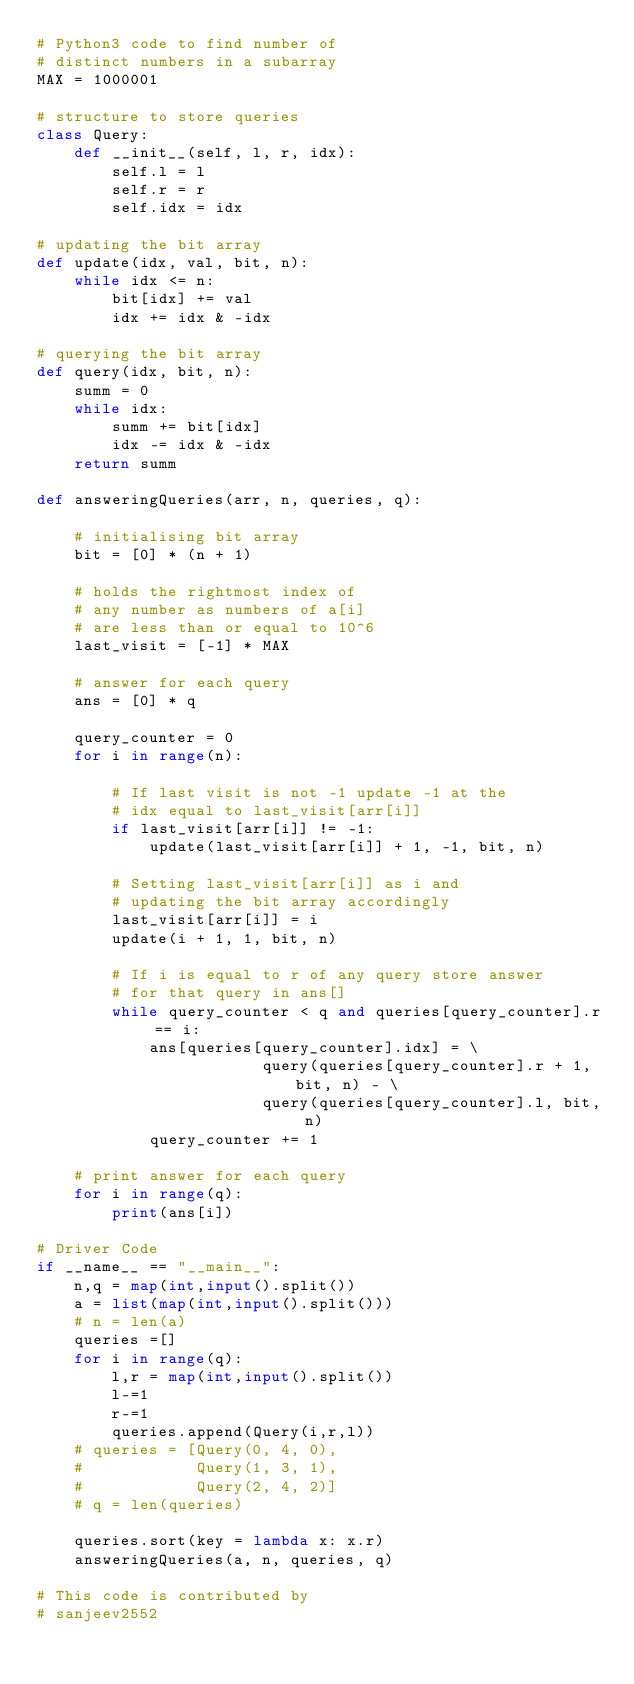<code> <loc_0><loc_0><loc_500><loc_500><_Python_># Python3 code to find number of  
# distinct numbers in a subarray 
MAX = 1000001
  
# structure to store queries 
class Query: 
    def __init__(self, l, r, idx): 
        self.l = l 
        self.r = r 
        self.idx = idx 
  
# updating the bit array 
def update(idx, val, bit, n): 
    while idx <= n: 
        bit[idx] += val 
        idx += idx & -idx 
  
# querying the bit array 
def query(idx, bit, n): 
    summ = 0
    while idx: 
        summ += bit[idx] 
        idx -= idx & -idx 
    return summ 
  
def answeringQueries(arr, n, queries, q): 
  
    # initialising bit array 
    bit = [0] * (n + 1) 
  
    # holds the rightmost index of  
    # any number as numbers of a[i] 
    # are less than or equal to 10^6 
    last_visit = [-1] * MAX
  
    # answer for each query 
    ans = [0] * q 
  
    query_counter = 0
    for i in range(n): 
  
        # If last visit is not -1 update -1 at the 
        # idx equal to last_visit[arr[i]] 
        if last_visit[arr[i]] != -1: 
            update(last_visit[arr[i]] + 1, -1, bit, n) 
  
        # Setting last_visit[arr[i]] as i and  
        # updating the bit array accordingly 
        last_visit[arr[i]] = i 
        update(i + 1, 1, bit, n) 
  
        # If i is equal to r of any query store answer 
        # for that query in ans[] 
        while query_counter < q and queries[query_counter].r == i: 
            ans[queries[query_counter].idx] = \ 
                        query(queries[query_counter].r + 1, bit, n) - \ 
                        query(queries[query_counter].l, bit, n) 
            query_counter += 1
  
    # print answer for each query 
    for i in range(q): 
        print(ans[i]) 
  
# Driver Code 
if __name__ == "__main__":
    n,q = map(int,input().split())
    a = list(map(int,input().split()))
    # n = len(a)
    queries =[]
    for i in range(q):
        l,r = map(int,input().split())
        l-=1
        r-=1
        queries.append(Query(i,r,l))
    # queries = [Query(0, 4, 0),
    #            Query(1, 3, 1),
    #            Query(2, 4, 2)]
    # q = len(queries)
  
    queries.sort(key = lambda x: x.r) 
    answeringQueries(a, n, queries, q) 
  
# This code is contributed by 
# sanjeev2552 
</code> 